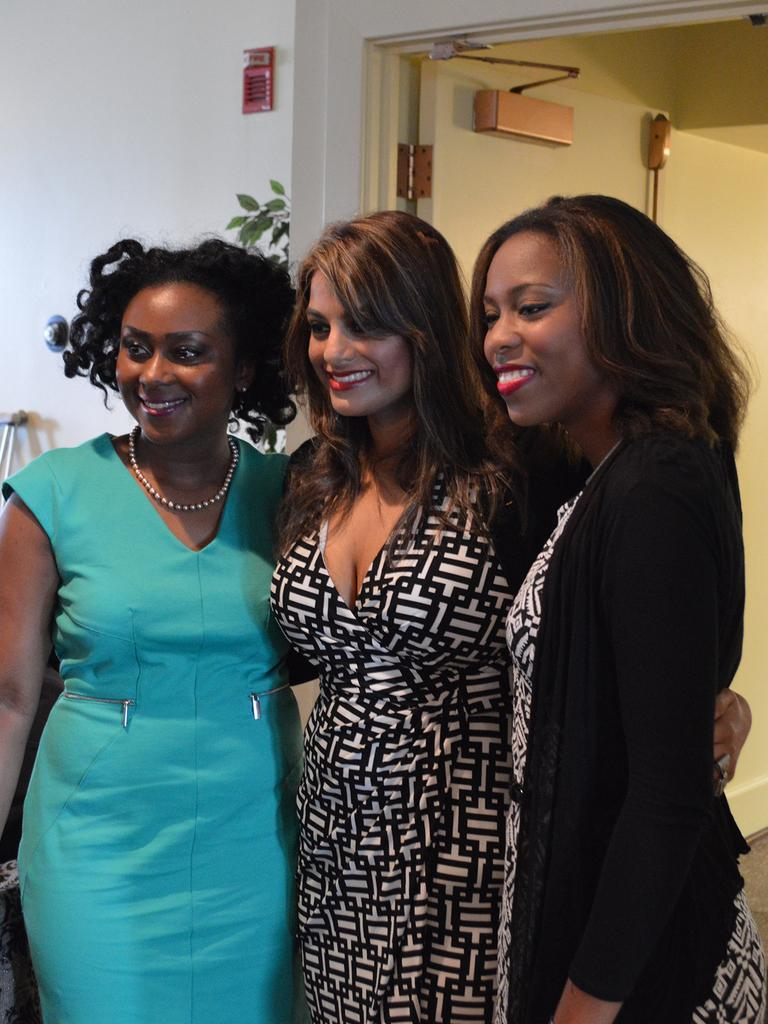How many women are in the image? There are three women in the image. What are the women doing in the image? The women are standing on the floor and smiling. What can be seen in the background of the image? There is a wall, a plant, and other objects visible in the background of the image. Are the women in the image getting ready to join the beds in the bedroom? There is no mention of a bedroom or beds in the image, and the women are not shown preparing to join any beds. 